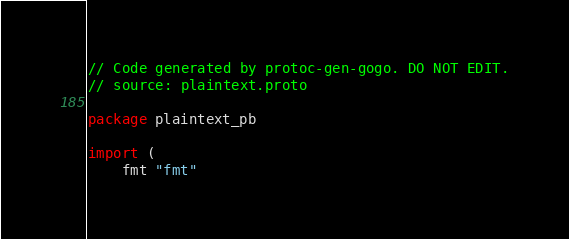<code> <loc_0><loc_0><loc_500><loc_500><_Go_>// Code generated by protoc-gen-gogo. DO NOT EDIT.
// source: plaintext.proto

package plaintext_pb

import (
	fmt "fmt"</code> 